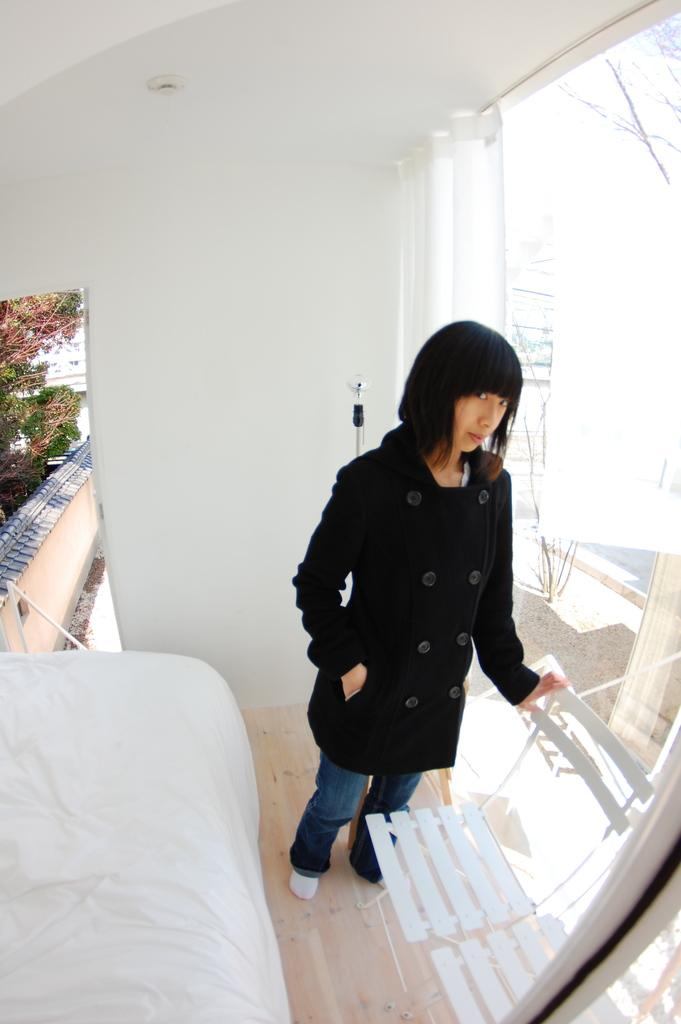Who is present in the image? There is a woman in the image. What is the woman wearing? The woman is wearing a black coat and blue trousers. What can be seen on the right side of the image? There is a glass wall on the right side of the image. What type of furniture is visible at the bottom of the image? There are white chairs at the bottom of the image. What news headline is visible on the woman's notebook in the image? There is no notebook present in the image, and therefore no news headline can be observed. 